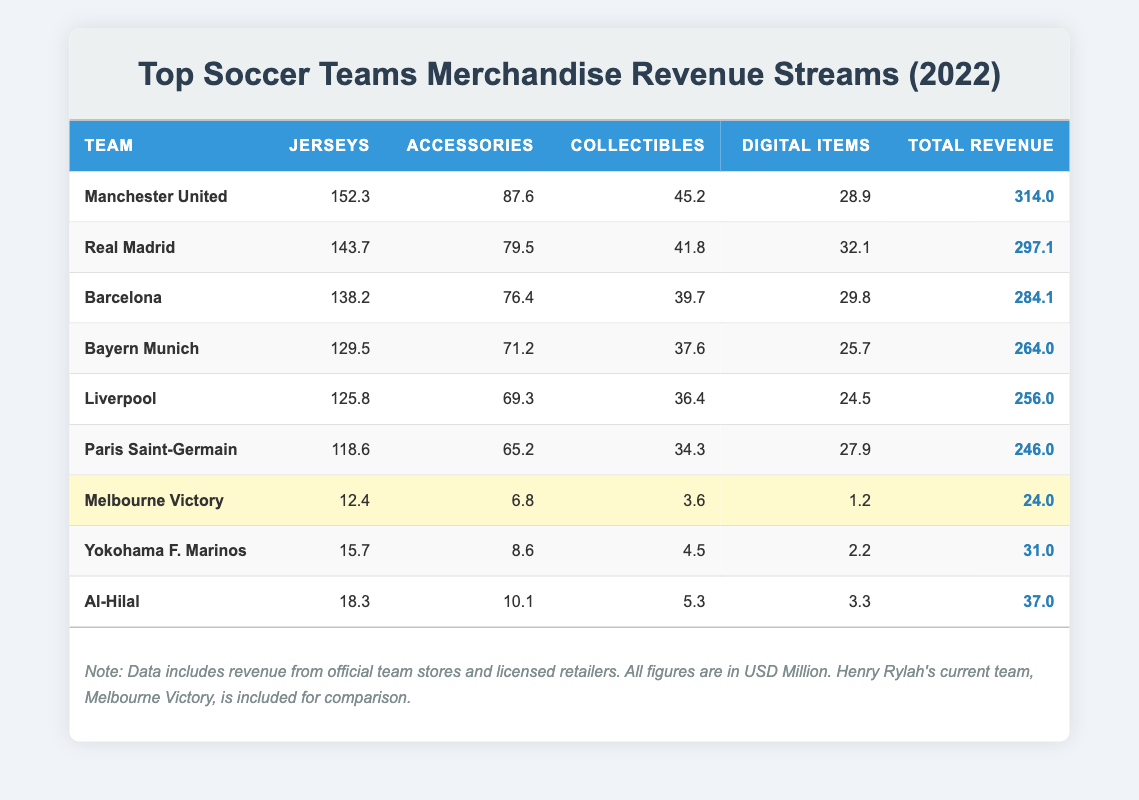What is the total revenue from merchandise sales for Barcelona? The table lists the total revenue for Barcelona as 284.1 million USD.
Answer: 284.1 million USD Which team has the highest revenue from accessories? Looking at the accessories column, Manchester United has the highest revenue at 87.6 million USD.
Answer: Manchester United How much more revenue does Liverpool generate from jerseys compared to Melbourne Victory? Liverpool generates 125.8 million USD from jerseys, while Melbourne Victory generates 12.4 million USD. The difference is 125.8 - 12.4 = 113.4 million USD.
Answer: 113.4 million USD Is the total revenue for Paris Saint-Germain greater than that of Bayern Munich? Paris Saint-Germain has a total revenue of 246.0 million USD, while Bayern Munich has 264.0 million USD. Since 246.0 is less than 264.0, the statement is false.
Answer: No What is the combined revenue from digital items for the top three teams? The total revenues from digital items for the top three teams are: Manchester United (28.9), Real Madrid (32.1), and Barcelona (29.8). Summing these up: 28.9 + 32.1 + 29.8 = 90.8 million USD.
Answer: 90.8 million USD Which team has the lowest total revenue from merchandise sales? The table shows that Melbourne Victory has the lowest total revenue at 24.0 million USD.
Answer: Melbourne Victory What percentage of Manchester United's total revenue comes from jersey sales? The total revenue for Manchester United is 314.0 million USD, and jersey sales account for 152.3 million USD. To find the percentage, we calculate (152.3 / 314.0) * 100, which equals approximately 48.5%.
Answer: 48.5% Which team has the highest revenue from collectibles? When checking the collectibles column, Manchester United leads with 45.2 million USD in revenue from collectibles.
Answer: Manchester United How does the total revenue of Yokohama F. Marinos compare to that of Al-Hilal? Yokohama F. Marinos has a total revenue of 31.0 million USD, while Al-Hilal has 37.0 million USD. Since 31.0 is less than 37.0, Yokohama F. Marinos has a lower total revenue.
Answer: Lower 